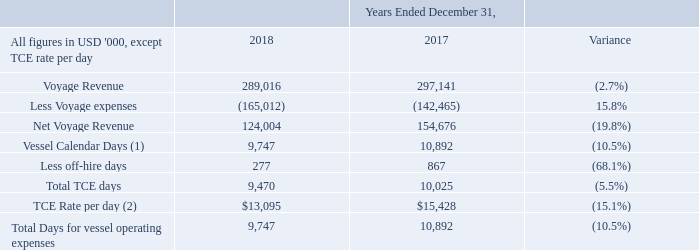Reconciliation of net voyage revenues to voyage revenues:
(1) Vessel Calendar Days is the total number of days the vessels were in our fleet.
(2) Time Charter Equivalent ("TCE") Rate, results from Net Voyage Revenue divided by total TCE days.
What are the respective voyage revenue in 2017 and 2018?
Answer scale should be: thousand. 297,141, 289,016. What are the respective voyage expenses in 2017 and 2018?
Answer scale should be: thousand. 142,465, 165,012. What are the respective net voyage revenue in 2017 and 2018?
Answer scale should be: thousand. 154,676, 124,004. What is the value of the voyage revenue in 2017 as a percentage of the revenue in 2018?
Answer scale should be: percent. 297,141/289,016 
Answer: 102.81. What is the value of the voyage expenses in 2017 as a percentage of the expenses in 2018?
Answer scale should be: percent. 142,465/165,012 
Answer: 86.34. What is the value of the net voyage revenue in 2017 as a percentage of the net voyage revenue in 2018?
Answer scale should be: percent. 154,676/124,004 
Answer: 124.73. 